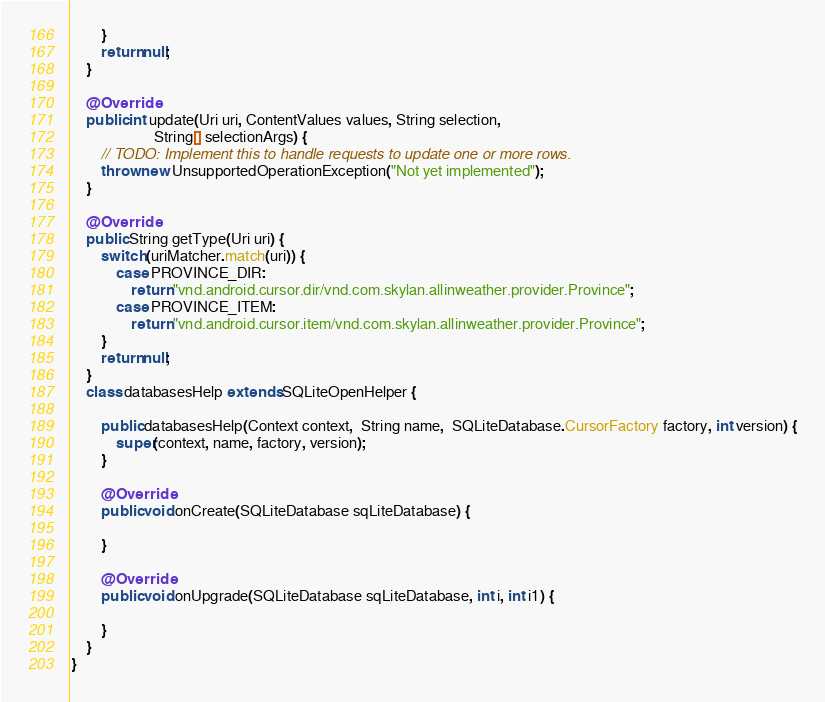Convert code to text. <code><loc_0><loc_0><loc_500><loc_500><_Java_>        }
        return null;
    }

    @Override
    public int update(Uri uri, ContentValues values, String selection,
                      String[] selectionArgs) {
        // TODO: Implement this to handle requests to update one or more rows.
        throw new UnsupportedOperationException("Not yet implemented");
    }

    @Override
    public String getType(Uri uri) {
        switch (uriMatcher.match(uri)) {
            case PROVINCE_DIR:
                return "vnd.android.cursor.dir/vnd.com.skylan.allinweather.provider.Province";
            case PROVINCE_ITEM:
                return "vnd.android.cursor.item/vnd.com.skylan.allinweather.provider.Province";
        }
        return null;
    }
    class databasesHelp extends SQLiteOpenHelper {

        public databasesHelp(Context context,  String name,  SQLiteDatabase.CursorFactory factory, int version) {
            super(context, name, factory, version);
        }

        @Override
        public void onCreate(SQLiteDatabase sqLiteDatabase) {

        }

        @Override
        public void onUpgrade(SQLiteDatabase sqLiteDatabase, int i, int i1) {

        }
    }
}
</code> 